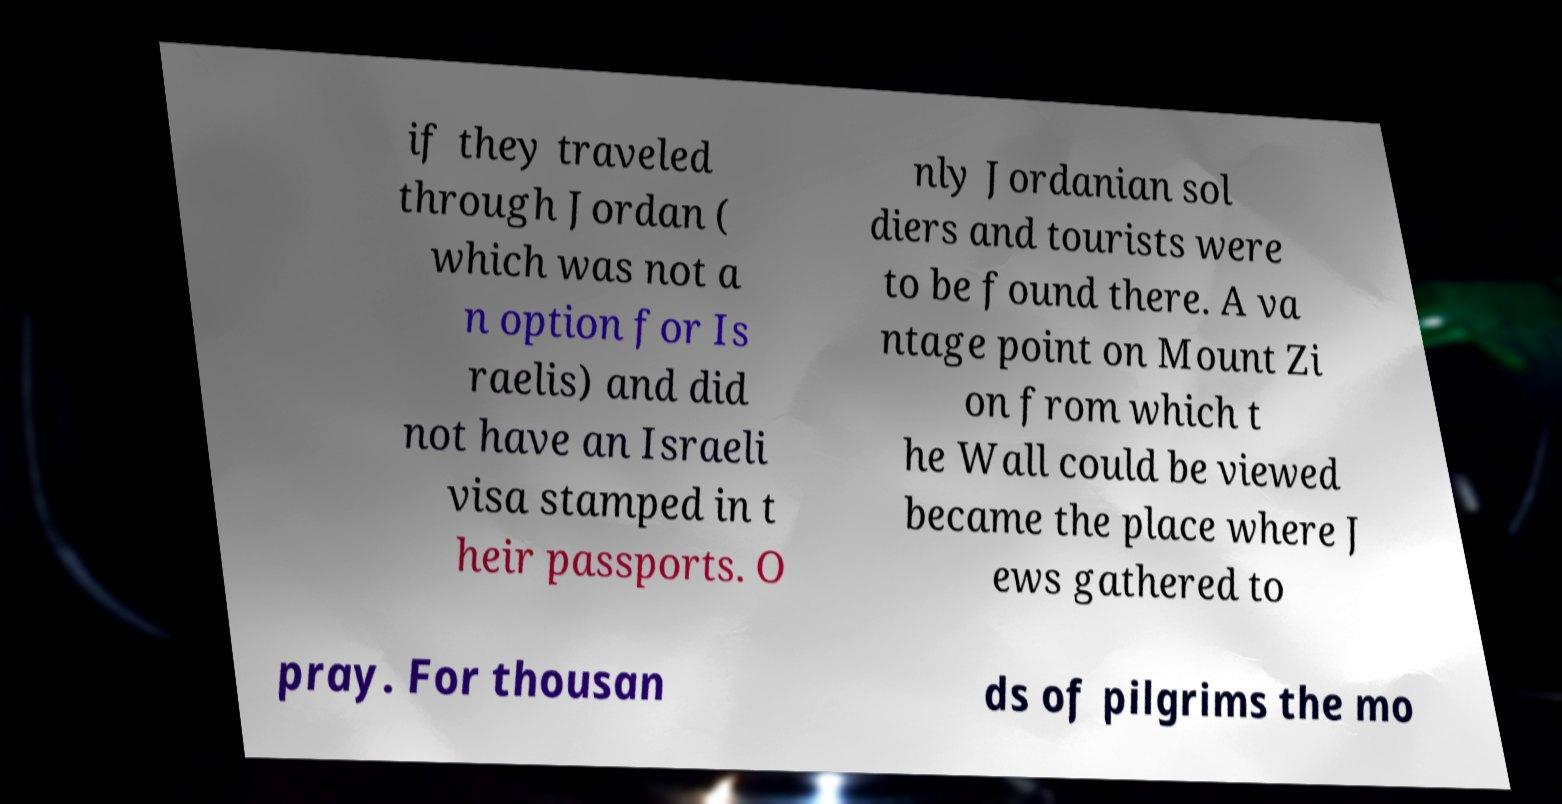There's text embedded in this image that I need extracted. Can you transcribe it verbatim? if they traveled through Jordan ( which was not a n option for Is raelis) and did not have an Israeli visa stamped in t heir passports. O nly Jordanian sol diers and tourists were to be found there. A va ntage point on Mount Zi on from which t he Wall could be viewed became the place where J ews gathered to pray. For thousan ds of pilgrims the mo 